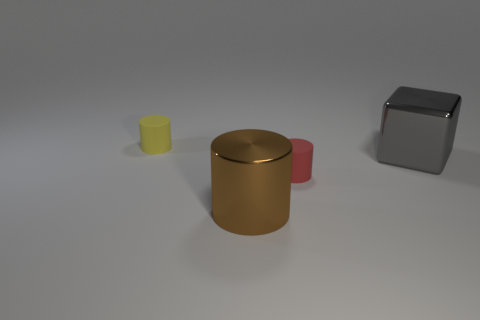What number of other things are the same shape as the tiny red object?
Provide a succinct answer. 2. Is the size of the red rubber thing that is in front of the large gray object the same as the block that is in front of the small yellow cylinder?
Keep it short and to the point. No. What number of blocks are either matte objects or brown metal objects?
Provide a short and direct response. 0. How many metallic things are either large objects or blocks?
Your answer should be compact. 2. There is a red object that is the same shape as the brown thing; what size is it?
Offer a very short reply. Small. Is there anything else that has the same size as the metallic cylinder?
Offer a terse response. Yes. There is a red rubber cylinder; is its size the same as the matte cylinder to the left of the big shiny cylinder?
Provide a short and direct response. Yes. There is a big metal object on the left side of the big block; what shape is it?
Your answer should be very brief. Cylinder. The small cylinder that is behind the metallic thing behind the red object is what color?
Your answer should be very brief. Yellow. There is a large object that is the same shape as the small yellow rubber object; what is its color?
Provide a succinct answer. Brown. 